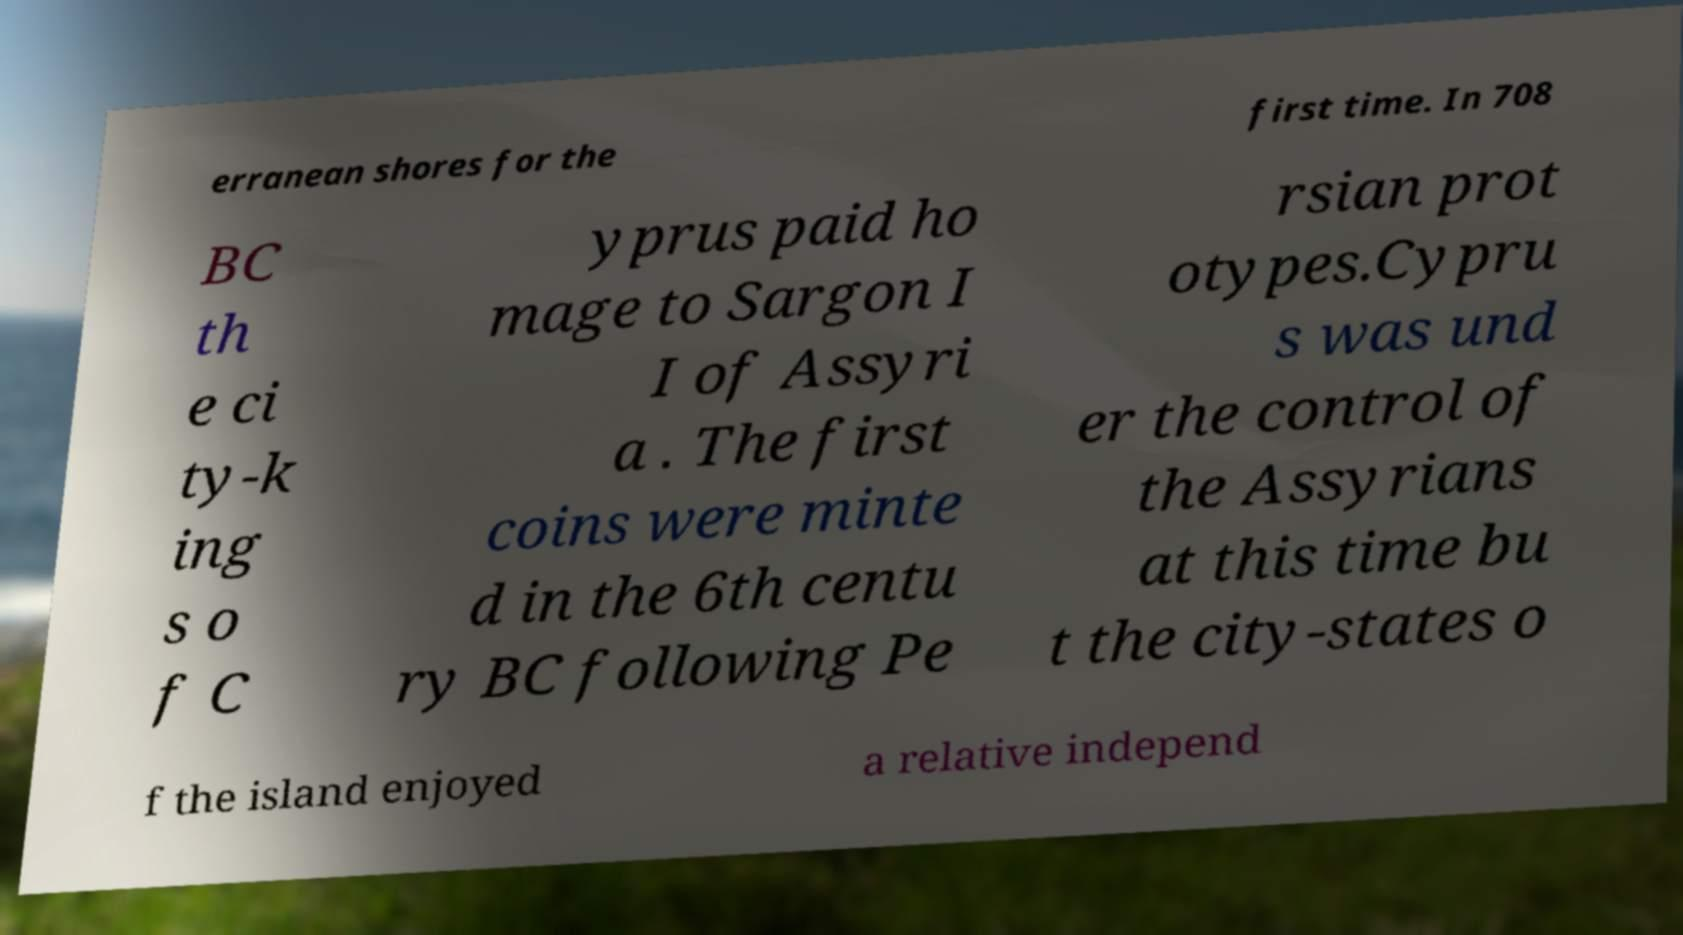Please read and relay the text visible in this image. What does it say? erranean shores for the first time. In 708 BC th e ci ty-k ing s o f C yprus paid ho mage to Sargon I I of Assyri a . The first coins were minte d in the 6th centu ry BC following Pe rsian prot otypes.Cypru s was und er the control of the Assyrians at this time bu t the city-states o f the island enjoyed a relative independ 